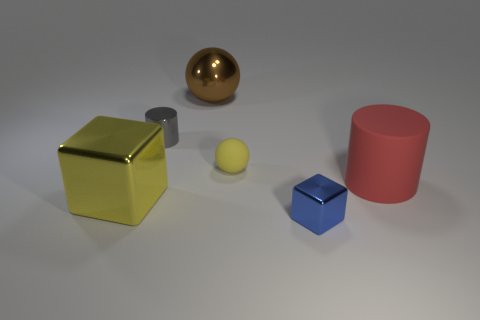What material is the big red thing that is the same shape as the gray object?
Make the answer very short. Rubber. What material is the other object that is the same color as the tiny matte thing?
Give a very brief answer. Metal. There is a small gray shiny cylinder left of the yellow matte object; how many shiny cubes are right of it?
Make the answer very short. 1. Do the small object that is in front of the matte ball and the small metal object behind the red cylinder have the same color?
Offer a terse response. No. What material is the red cylinder that is the same size as the brown thing?
Offer a terse response. Rubber. The shiny object that is left of the tiny metallic object behind the thing in front of the yellow cube is what shape?
Keep it short and to the point. Cube. There is a yellow matte object that is the same size as the blue block; what shape is it?
Offer a very short reply. Sphere. What number of metallic objects are to the right of the rubber thing in front of the sphere that is in front of the brown ball?
Ensure brevity in your answer.  0. Is the number of tiny shiny cylinders that are behind the shiny cylinder greater than the number of tiny yellow objects right of the large matte cylinder?
Keep it short and to the point. No. What number of gray metal objects are the same shape as the big red object?
Your answer should be compact. 1. 